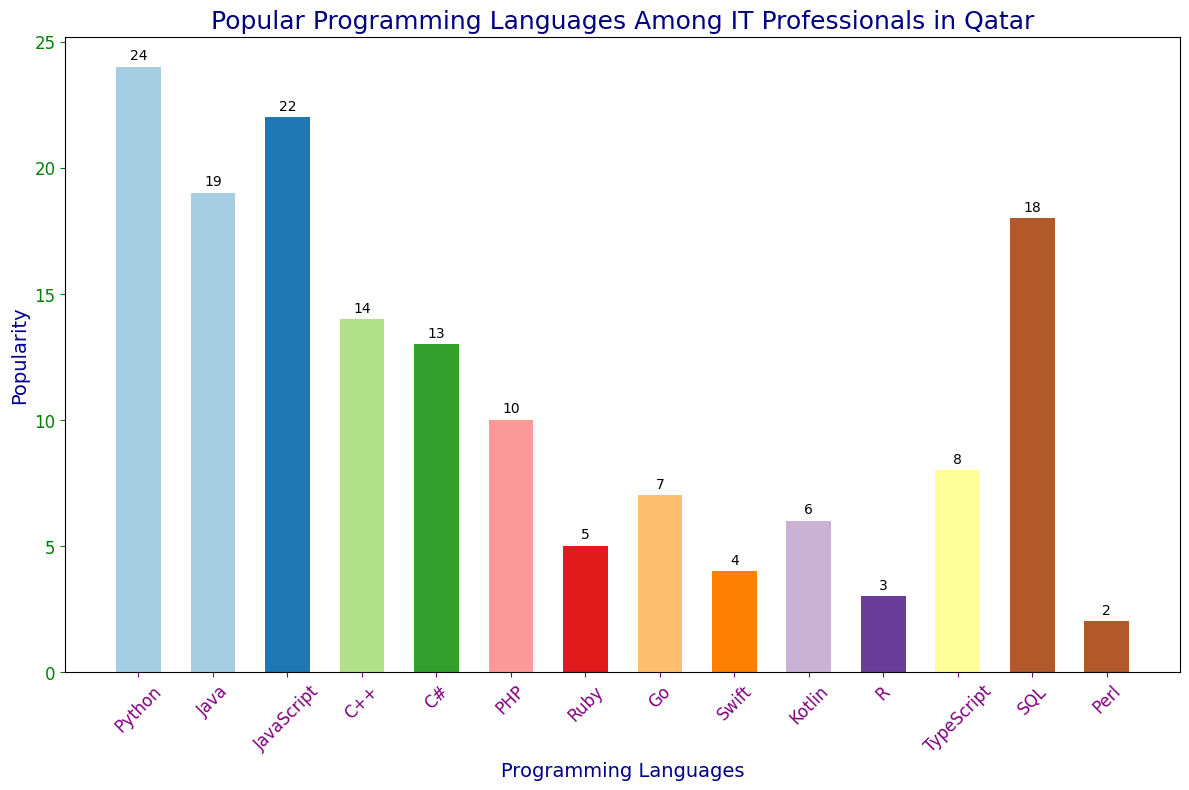what programming language is the most popular among IT professionals in Qatar? The tallest bar on the chart represents Python with its height indicating it has the highest popularity count among the programming languages displayed.
Answer: Python What is the total popularity of Python and JavaScript combined? The bars for Python and JavaScript have heights representing popularity values of 24 and 22 respectively. Adding these values together gives the combined popularity: 24 + 22.
Answer: 46 How many more IT professionals use Python compared to Swift? The bar for Python has a popularity value of 24 while the bar for Swift has a value of 4. The difference between the two is calculated by subtracting the smaller value from the larger one: 24 - 4.
Answer: 20 Which programming language has slightly more popularity than PHP but less than Kotlin? By observing the heights of the bars, PHP has a popularity of 10 and Kotlin has a popularity of 6. The bar for TypeScript, which has a popularity value of 8, fits this condition of being more than 6 but less than 10.
Answer: TypeScript What is the least popular programming language among IT professionals in Qatar? The shortest bar on the chart, indicating the lowest popularity, represents Perl with a popularity of 2.
Answer: Perl Which languages have a popularity greater than 15? By examining the heights of the bars, the languages with popularity values greater than 15 are Python (24), Java (19), JavaScript (22), and SQL (18).
Answer: Python, Java, JavaScript, SQL What is the sum of the popularity of programming languages with a value less than 6? The bars for the programming languages Ruby (5), Swift (4), Kotlin (6), R (3), and Perl (2) fall in this category. Summing their popularity values: 5 + 4 + 3 + 2.
Answer: 14 Which programming language is more popular: SQL or C++? By comparing the heights of the bars, we see that SQL has a popularity value of 18, while C++ has a value of 14, making SQL the more popular language.
Answer: SQL What is the average popularity of C++, PHP, Ruby, and Go? Summing the popularity values of C++ (14), PHP (10), Ruby (5), and Go (7), then dividing by the number of languages (4), ((14 + 10 + 5 + 7) / 4).
Answer: 9 Is the popularity of JavaScript higher than the average popularity of all languages? First, calculate the total popularity of all languages (24+19+22+14+13+10+5+7+4+6+3+8+18+2) = 155. There are 14 languages, so the average popularity is 155 / 14 ≈ 11.07. JavaScript has a popularity value of 22, which is greater than this average.
Answer: Yes 